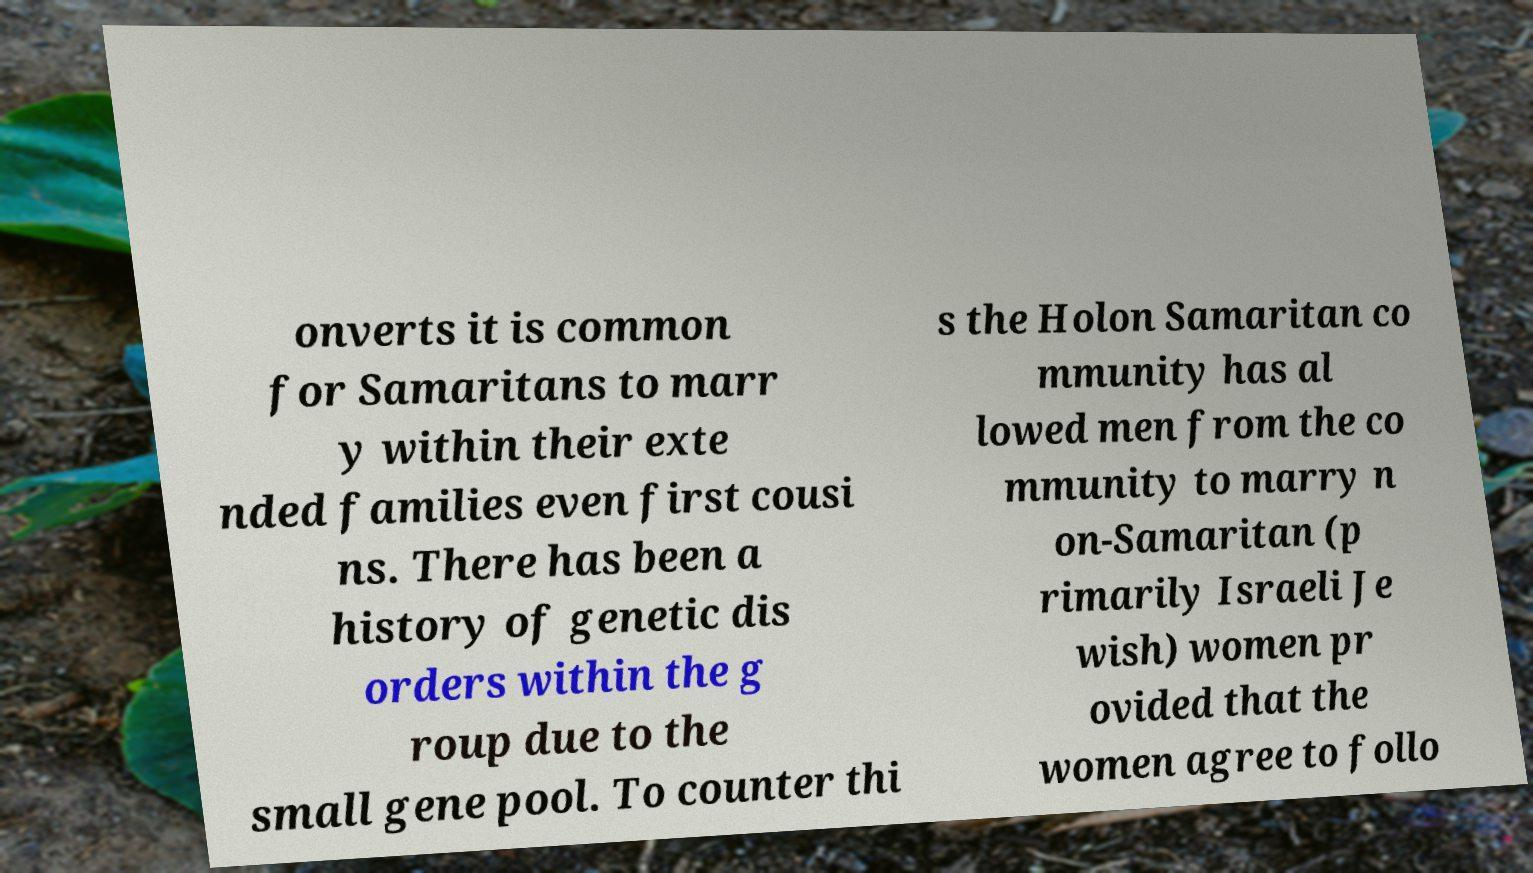There's text embedded in this image that I need extracted. Can you transcribe it verbatim? onverts it is common for Samaritans to marr y within their exte nded families even first cousi ns. There has been a history of genetic dis orders within the g roup due to the small gene pool. To counter thi s the Holon Samaritan co mmunity has al lowed men from the co mmunity to marry n on-Samaritan (p rimarily Israeli Je wish) women pr ovided that the women agree to follo 